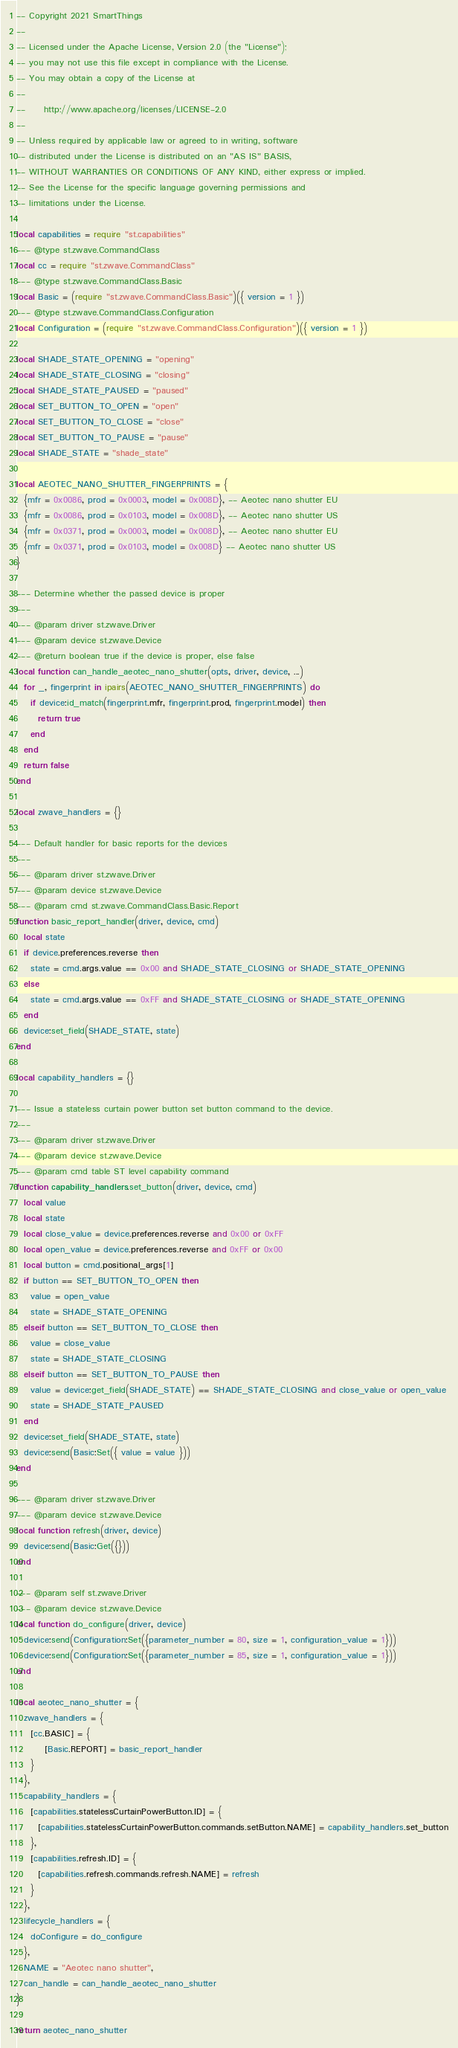Convert code to text. <code><loc_0><loc_0><loc_500><loc_500><_Lua_>-- Copyright 2021 SmartThings
--
-- Licensed under the Apache License, Version 2.0 (the "License");
-- you may not use this file except in compliance with the License.
-- You may obtain a copy of the License at
--
--     http://www.apache.org/licenses/LICENSE-2.0
--
-- Unless required by applicable law or agreed to in writing, software
-- distributed under the License is distributed on an "AS IS" BASIS,
-- WITHOUT WARRANTIES OR CONDITIONS OF ANY KIND, either express or implied.
-- See the License for the specific language governing permissions and
-- limitations under the License.

local capabilities = require "st.capabilities"
--- @type st.zwave.CommandClass
local cc = require "st.zwave.CommandClass"
--- @type st.zwave.CommandClass.Basic
local Basic = (require "st.zwave.CommandClass.Basic")({ version = 1 })
--- @type st.zwave.CommandClass.Configuration
local Configuration = (require "st.zwave.CommandClass.Configuration")({ version = 1 })

local SHADE_STATE_OPENING = "opening"
local SHADE_STATE_CLOSING = "closing"
local SHADE_STATE_PAUSED = "paused"
local SET_BUTTON_TO_OPEN = "open"
local SET_BUTTON_TO_CLOSE = "close"
local SET_BUTTON_TO_PAUSE = "pause"
local SHADE_STATE = "shade_state"

local AEOTEC_NANO_SHUTTER_FINGERPRINTS = {
  {mfr = 0x0086, prod = 0x0003, model = 0x008D}, -- Aeotec nano shutter EU
  {mfr = 0x0086, prod = 0x0103, model = 0x008D}, -- Aeotec nano shutter US
  {mfr = 0x0371, prod = 0x0003, model = 0x008D}, -- Aeotec nano shutter EU
  {mfr = 0x0371, prod = 0x0103, model = 0x008D} -- Aeotec nano shutter US
}

--- Determine whether the passed device is proper
---
--- @param driver st.zwave.Driver
--- @param device st.zwave.Device
--- @return boolean true if the device is proper, else false
local function can_handle_aeotec_nano_shutter(opts, driver, device, ...)
  for _, fingerprint in ipairs(AEOTEC_NANO_SHUTTER_FINGERPRINTS) do
    if device:id_match(fingerprint.mfr, fingerprint.prod, fingerprint.model) then
      return true
    end
  end
  return false
end

local zwave_handlers = {}

--- Default handler for basic reports for the devices
---
--- @param driver st.zwave.Driver
--- @param device st.zwave.Device
--- @param cmd st.zwave.CommandClass.Basic.Report
function basic_report_handler(driver, device, cmd)
  local state
  if device.preferences.reverse then
    state = cmd.args.value == 0x00 and SHADE_STATE_CLOSING or SHADE_STATE_OPENING
  else
    state = cmd.args.value == 0xFF and SHADE_STATE_CLOSING or SHADE_STATE_OPENING
  end
  device:set_field(SHADE_STATE, state)
end

local capability_handlers = {}

--- Issue a stateless curtain power button set button command to the device.
---
--- @param driver st.zwave.Driver
--- @param device st.zwave.Device
--- @param cmd table ST level capability command
function capability_handlers.set_button(driver, device, cmd)
  local value
  local state
  local close_value = device.preferences.reverse and 0x00 or 0xFF
  local open_value = device.preferences.reverse and 0xFF or 0x00
  local button = cmd.positional_args[1]
  if button == SET_BUTTON_TO_OPEN then
    value = open_value
    state = SHADE_STATE_OPENING
  elseif button == SET_BUTTON_TO_CLOSE then
    value = close_value
    state = SHADE_STATE_CLOSING
  elseif button == SET_BUTTON_TO_PAUSE then
    value = device:get_field(SHADE_STATE) == SHADE_STATE_CLOSING and close_value or open_value
    state = SHADE_STATE_PAUSED
  end
  device:set_field(SHADE_STATE, state)
  device:send(Basic:Set({ value = value }))
end

--- @param driver st.zwave.Driver
--- @param device st.zwave.Device
local function refresh(driver, device)
  device:send(Basic:Get({}))
end

--- @param self st.zwave.Driver
--- @param device st.zwave.Device
local function do_configure(driver, device)
  device:send(Configuration:Set({parameter_number = 80, size = 1, configuration_value = 1}))
  device:send(Configuration:Set({parameter_number = 85, size = 1, configuration_value = 1}))
end

local aeotec_nano_shutter = {
  zwave_handlers = {
    [cc.BASIC] = {
        [Basic.REPORT] = basic_report_handler
    }
  },
  capability_handlers = {
    [capabilities.statelessCurtainPowerButton.ID] = {
      [capabilities.statelessCurtainPowerButton.commands.setButton.NAME] = capability_handlers.set_button
    },
    [capabilities.refresh.ID] = { 
      [capabilities.refresh.commands.refresh.NAME] = refresh 
    }
  },
  lifecycle_handlers = {
    doConfigure = do_configure
  },
  NAME = "Aeotec nano shutter",
  can_handle = can_handle_aeotec_nano_shutter
}

return aeotec_nano_shutter
</code> 